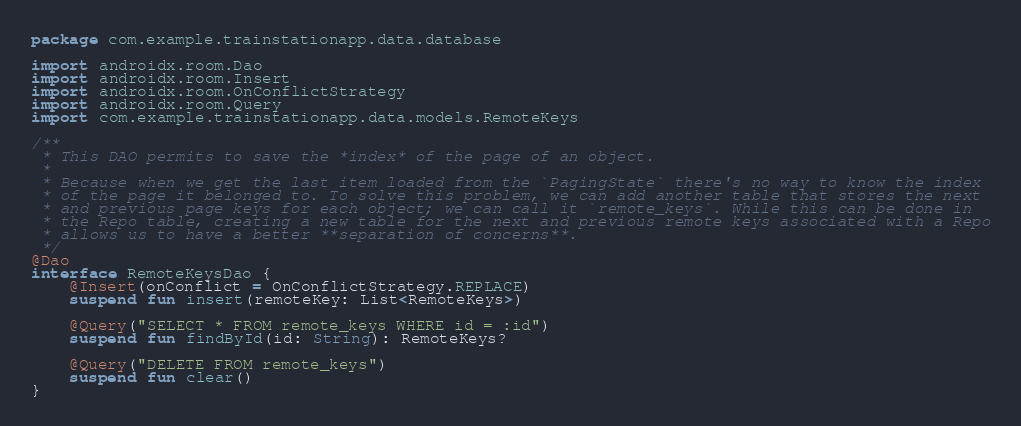Convert code to text. <code><loc_0><loc_0><loc_500><loc_500><_Kotlin_>package com.example.trainstationapp.data.database

import androidx.room.Dao
import androidx.room.Insert
import androidx.room.OnConflictStrategy
import androidx.room.Query
import com.example.trainstationapp.data.models.RemoteKeys

/**
 * This DAO permits to save the *index* of the page of an object.
 *
 * Because when we get the last item loaded from the `PagingState` there's no way to know the index
 * of the page it belonged to. To solve this problem, we can add another table that stores the next
 * and previous page keys for each object; we can call it `remote_keys`. While this can be done in
 * the Repo table, creating a new table for the next and previous remote keys associated with a Repo
 * allows us to have a better **separation of concerns**.
 */
@Dao
interface RemoteKeysDao {
    @Insert(onConflict = OnConflictStrategy.REPLACE)
    suspend fun insert(remoteKey: List<RemoteKeys>)

    @Query("SELECT * FROM remote_keys WHERE id = :id")
    suspend fun findById(id: String): RemoteKeys?

    @Query("DELETE FROM remote_keys")
    suspend fun clear()
}
</code> 